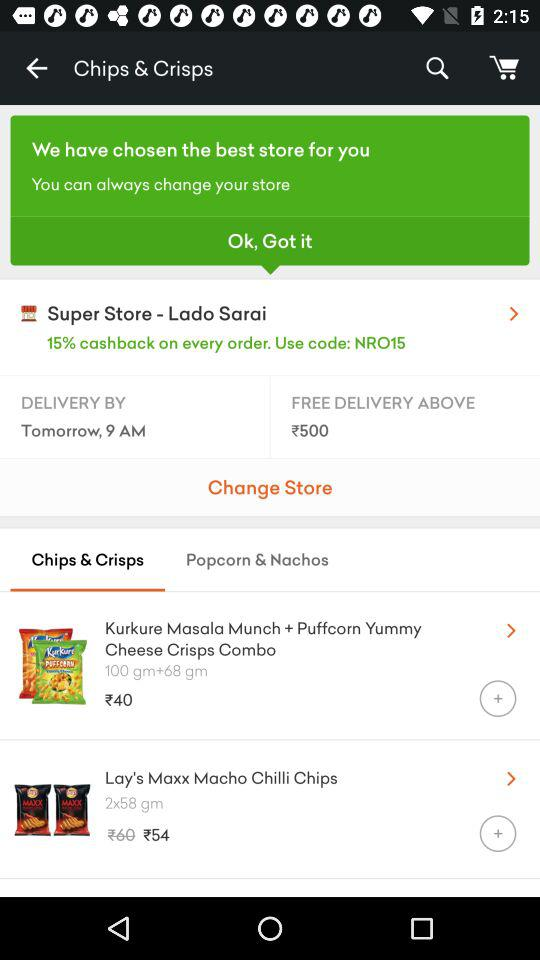What is the delivery date?
When the provided information is insufficient, respond with <no answer>. <no answer> 